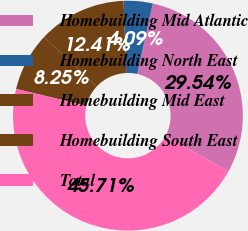<chart> <loc_0><loc_0><loc_500><loc_500><pie_chart><fcel>Homebuilding Mid Atlantic<fcel>Homebuilding North East<fcel>Homebuilding Mid East<fcel>Homebuilding South East<fcel>Total<nl><fcel>29.54%<fcel>4.09%<fcel>12.41%<fcel>8.25%<fcel>45.71%<nl></chart> 